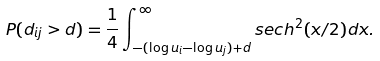Convert formula to latex. <formula><loc_0><loc_0><loc_500><loc_500>P ( d _ { i j } > d ) = \frac { 1 } { 4 } \int _ { - ( \log u _ { i } - \log u _ { j } ) + d } ^ { \infty } s e c h ^ { 2 } ( x / 2 ) d x .</formula> 